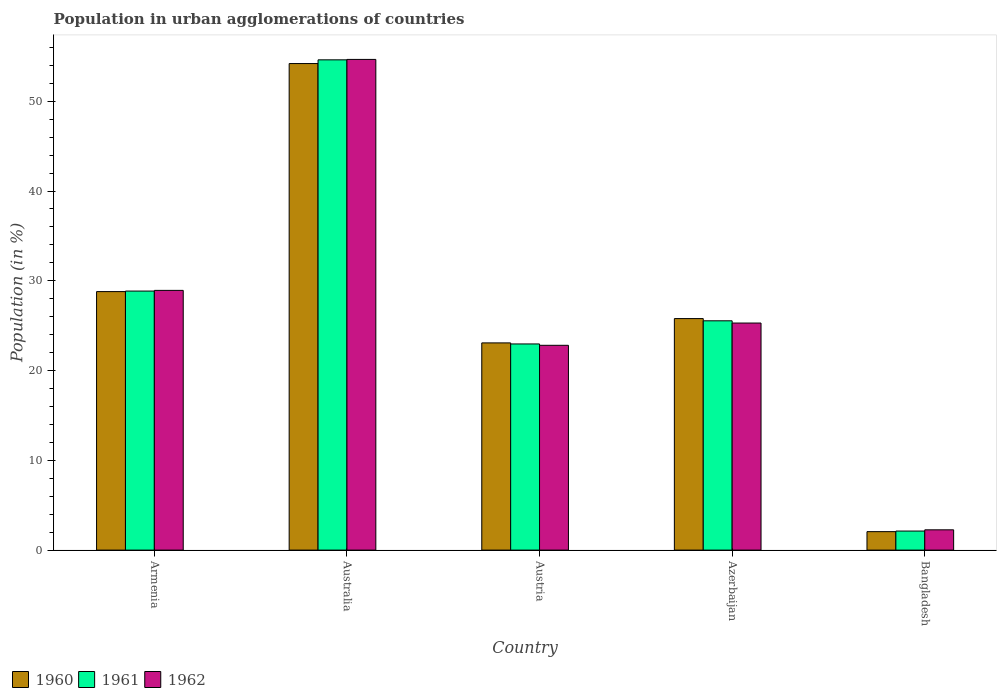How many different coloured bars are there?
Keep it short and to the point. 3. How many groups of bars are there?
Your answer should be very brief. 5. Are the number of bars per tick equal to the number of legend labels?
Keep it short and to the point. Yes. How many bars are there on the 2nd tick from the left?
Provide a short and direct response. 3. In how many cases, is the number of bars for a given country not equal to the number of legend labels?
Give a very brief answer. 0. What is the percentage of population in urban agglomerations in 1961 in Armenia?
Ensure brevity in your answer.  28.85. Across all countries, what is the maximum percentage of population in urban agglomerations in 1962?
Your answer should be compact. 54.66. Across all countries, what is the minimum percentage of population in urban agglomerations in 1962?
Keep it short and to the point. 2.26. In which country was the percentage of population in urban agglomerations in 1961 minimum?
Your answer should be compact. Bangladesh. What is the total percentage of population in urban agglomerations in 1960 in the graph?
Provide a short and direct response. 133.93. What is the difference between the percentage of population in urban agglomerations in 1960 in Australia and that in Austria?
Provide a short and direct response. 31.12. What is the difference between the percentage of population in urban agglomerations in 1962 in Austria and the percentage of population in urban agglomerations in 1961 in Bangladesh?
Keep it short and to the point. 20.69. What is the average percentage of population in urban agglomerations in 1961 per country?
Ensure brevity in your answer.  26.82. What is the difference between the percentage of population in urban agglomerations of/in 1960 and percentage of population in urban agglomerations of/in 1961 in Armenia?
Offer a very short reply. -0.06. In how many countries, is the percentage of population in urban agglomerations in 1960 greater than 46 %?
Your answer should be very brief. 1. What is the ratio of the percentage of population in urban agglomerations in 1961 in Armenia to that in Australia?
Your response must be concise. 0.53. What is the difference between the highest and the second highest percentage of population in urban agglomerations in 1960?
Make the answer very short. -3.01. What is the difference between the highest and the lowest percentage of population in urban agglomerations in 1961?
Give a very brief answer. 52.49. What does the 1st bar from the right in Azerbaijan represents?
Offer a very short reply. 1962. How many bars are there?
Offer a terse response. 15. How many countries are there in the graph?
Ensure brevity in your answer.  5. Are the values on the major ticks of Y-axis written in scientific E-notation?
Offer a terse response. No. Does the graph contain any zero values?
Ensure brevity in your answer.  No. Does the graph contain grids?
Your answer should be compact. No. Where does the legend appear in the graph?
Keep it short and to the point. Bottom left. How are the legend labels stacked?
Ensure brevity in your answer.  Horizontal. What is the title of the graph?
Give a very brief answer. Population in urban agglomerations of countries. What is the label or title of the X-axis?
Keep it short and to the point. Country. What is the label or title of the Y-axis?
Your answer should be very brief. Population (in %). What is the Population (in %) in 1960 in Armenia?
Offer a terse response. 28.8. What is the Population (in %) in 1961 in Armenia?
Keep it short and to the point. 28.85. What is the Population (in %) in 1962 in Armenia?
Provide a short and direct response. 28.93. What is the Population (in %) of 1960 in Australia?
Offer a very short reply. 54.2. What is the Population (in %) of 1961 in Australia?
Your answer should be very brief. 54.62. What is the Population (in %) of 1962 in Australia?
Provide a short and direct response. 54.66. What is the Population (in %) in 1960 in Austria?
Keep it short and to the point. 23.08. What is the Population (in %) in 1961 in Austria?
Give a very brief answer. 22.96. What is the Population (in %) of 1962 in Austria?
Your answer should be compact. 22.81. What is the Population (in %) in 1960 in Azerbaijan?
Make the answer very short. 25.79. What is the Population (in %) of 1961 in Azerbaijan?
Keep it short and to the point. 25.54. What is the Population (in %) of 1962 in Azerbaijan?
Ensure brevity in your answer.  25.29. What is the Population (in %) in 1960 in Bangladesh?
Make the answer very short. 2.06. What is the Population (in %) in 1961 in Bangladesh?
Offer a very short reply. 2.12. What is the Population (in %) in 1962 in Bangladesh?
Keep it short and to the point. 2.26. Across all countries, what is the maximum Population (in %) of 1960?
Provide a short and direct response. 54.2. Across all countries, what is the maximum Population (in %) in 1961?
Provide a succinct answer. 54.62. Across all countries, what is the maximum Population (in %) in 1962?
Offer a very short reply. 54.66. Across all countries, what is the minimum Population (in %) in 1960?
Your response must be concise. 2.06. Across all countries, what is the minimum Population (in %) of 1961?
Ensure brevity in your answer.  2.12. Across all countries, what is the minimum Population (in %) of 1962?
Provide a short and direct response. 2.26. What is the total Population (in %) in 1960 in the graph?
Ensure brevity in your answer.  133.93. What is the total Population (in %) in 1961 in the graph?
Your answer should be very brief. 134.1. What is the total Population (in %) in 1962 in the graph?
Make the answer very short. 133.96. What is the difference between the Population (in %) in 1960 in Armenia and that in Australia?
Provide a short and direct response. -25.4. What is the difference between the Population (in %) in 1961 in Armenia and that in Australia?
Offer a terse response. -25.76. What is the difference between the Population (in %) in 1962 in Armenia and that in Australia?
Your answer should be very brief. -25.73. What is the difference between the Population (in %) of 1960 in Armenia and that in Austria?
Your answer should be very brief. 5.72. What is the difference between the Population (in %) of 1961 in Armenia and that in Austria?
Keep it short and to the point. 5.89. What is the difference between the Population (in %) of 1962 in Armenia and that in Austria?
Provide a succinct answer. 6.12. What is the difference between the Population (in %) in 1960 in Armenia and that in Azerbaijan?
Offer a very short reply. 3.01. What is the difference between the Population (in %) in 1961 in Armenia and that in Azerbaijan?
Keep it short and to the point. 3.31. What is the difference between the Population (in %) in 1962 in Armenia and that in Azerbaijan?
Your response must be concise. 3.64. What is the difference between the Population (in %) in 1960 in Armenia and that in Bangladesh?
Give a very brief answer. 26.74. What is the difference between the Population (in %) in 1961 in Armenia and that in Bangladesh?
Your response must be concise. 26.73. What is the difference between the Population (in %) in 1962 in Armenia and that in Bangladesh?
Ensure brevity in your answer.  26.67. What is the difference between the Population (in %) of 1960 in Australia and that in Austria?
Provide a short and direct response. 31.12. What is the difference between the Population (in %) of 1961 in Australia and that in Austria?
Make the answer very short. 31.65. What is the difference between the Population (in %) in 1962 in Australia and that in Austria?
Your answer should be compact. 31.85. What is the difference between the Population (in %) of 1960 in Australia and that in Azerbaijan?
Your response must be concise. 28.41. What is the difference between the Population (in %) of 1961 in Australia and that in Azerbaijan?
Your response must be concise. 29.07. What is the difference between the Population (in %) of 1962 in Australia and that in Azerbaijan?
Make the answer very short. 29.37. What is the difference between the Population (in %) in 1960 in Australia and that in Bangladesh?
Your answer should be very brief. 52.14. What is the difference between the Population (in %) of 1961 in Australia and that in Bangladesh?
Your answer should be very brief. 52.49. What is the difference between the Population (in %) in 1962 in Australia and that in Bangladesh?
Ensure brevity in your answer.  52.4. What is the difference between the Population (in %) of 1960 in Austria and that in Azerbaijan?
Your answer should be very brief. -2.71. What is the difference between the Population (in %) in 1961 in Austria and that in Azerbaijan?
Make the answer very short. -2.58. What is the difference between the Population (in %) of 1962 in Austria and that in Azerbaijan?
Keep it short and to the point. -2.48. What is the difference between the Population (in %) of 1960 in Austria and that in Bangladesh?
Make the answer very short. 21.03. What is the difference between the Population (in %) in 1961 in Austria and that in Bangladesh?
Offer a terse response. 20.84. What is the difference between the Population (in %) in 1962 in Austria and that in Bangladesh?
Your response must be concise. 20.56. What is the difference between the Population (in %) of 1960 in Azerbaijan and that in Bangladesh?
Ensure brevity in your answer.  23.74. What is the difference between the Population (in %) of 1961 in Azerbaijan and that in Bangladesh?
Keep it short and to the point. 23.42. What is the difference between the Population (in %) in 1962 in Azerbaijan and that in Bangladesh?
Your answer should be compact. 23.04. What is the difference between the Population (in %) of 1960 in Armenia and the Population (in %) of 1961 in Australia?
Offer a terse response. -25.82. What is the difference between the Population (in %) of 1960 in Armenia and the Population (in %) of 1962 in Australia?
Give a very brief answer. -25.86. What is the difference between the Population (in %) in 1961 in Armenia and the Population (in %) in 1962 in Australia?
Your response must be concise. -25.81. What is the difference between the Population (in %) of 1960 in Armenia and the Population (in %) of 1961 in Austria?
Make the answer very short. 5.83. What is the difference between the Population (in %) of 1960 in Armenia and the Population (in %) of 1962 in Austria?
Give a very brief answer. 5.98. What is the difference between the Population (in %) of 1961 in Armenia and the Population (in %) of 1962 in Austria?
Keep it short and to the point. 6.04. What is the difference between the Population (in %) of 1960 in Armenia and the Population (in %) of 1961 in Azerbaijan?
Give a very brief answer. 3.25. What is the difference between the Population (in %) in 1960 in Armenia and the Population (in %) in 1962 in Azerbaijan?
Your response must be concise. 3.5. What is the difference between the Population (in %) of 1961 in Armenia and the Population (in %) of 1962 in Azerbaijan?
Provide a succinct answer. 3.56. What is the difference between the Population (in %) of 1960 in Armenia and the Population (in %) of 1961 in Bangladesh?
Make the answer very short. 26.68. What is the difference between the Population (in %) in 1960 in Armenia and the Population (in %) in 1962 in Bangladesh?
Make the answer very short. 26.54. What is the difference between the Population (in %) in 1961 in Armenia and the Population (in %) in 1962 in Bangladesh?
Give a very brief answer. 26.6. What is the difference between the Population (in %) in 1960 in Australia and the Population (in %) in 1961 in Austria?
Your response must be concise. 31.24. What is the difference between the Population (in %) in 1960 in Australia and the Population (in %) in 1962 in Austria?
Provide a succinct answer. 31.39. What is the difference between the Population (in %) of 1961 in Australia and the Population (in %) of 1962 in Austria?
Make the answer very short. 31.8. What is the difference between the Population (in %) in 1960 in Australia and the Population (in %) in 1961 in Azerbaijan?
Your answer should be compact. 28.66. What is the difference between the Population (in %) in 1960 in Australia and the Population (in %) in 1962 in Azerbaijan?
Your answer should be very brief. 28.91. What is the difference between the Population (in %) in 1961 in Australia and the Population (in %) in 1962 in Azerbaijan?
Give a very brief answer. 29.32. What is the difference between the Population (in %) in 1960 in Australia and the Population (in %) in 1961 in Bangladesh?
Provide a short and direct response. 52.08. What is the difference between the Population (in %) of 1960 in Australia and the Population (in %) of 1962 in Bangladesh?
Provide a short and direct response. 51.94. What is the difference between the Population (in %) in 1961 in Australia and the Population (in %) in 1962 in Bangladesh?
Keep it short and to the point. 52.36. What is the difference between the Population (in %) of 1960 in Austria and the Population (in %) of 1961 in Azerbaijan?
Provide a succinct answer. -2.46. What is the difference between the Population (in %) in 1960 in Austria and the Population (in %) in 1962 in Azerbaijan?
Give a very brief answer. -2.21. What is the difference between the Population (in %) of 1961 in Austria and the Population (in %) of 1962 in Azerbaijan?
Make the answer very short. -2.33. What is the difference between the Population (in %) in 1960 in Austria and the Population (in %) in 1961 in Bangladesh?
Ensure brevity in your answer.  20.96. What is the difference between the Population (in %) of 1960 in Austria and the Population (in %) of 1962 in Bangladesh?
Your answer should be very brief. 20.82. What is the difference between the Population (in %) in 1961 in Austria and the Population (in %) in 1962 in Bangladesh?
Provide a succinct answer. 20.71. What is the difference between the Population (in %) in 1960 in Azerbaijan and the Population (in %) in 1961 in Bangladesh?
Provide a succinct answer. 23.67. What is the difference between the Population (in %) in 1960 in Azerbaijan and the Population (in %) in 1962 in Bangladesh?
Your answer should be very brief. 23.53. What is the difference between the Population (in %) of 1961 in Azerbaijan and the Population (in %) of 1962 in Bangladesh?
Make the answer very short. 23.28. What is the average Population (in %) in 1960 per country?
Keep it short and to the point. 26.79. What is the average Population (in %) of 1961 per country?
Keep it short and to the point. 26.82. What is the average Population (in %) in 1962 per country?
Your answer should be very brief. 26.79. What is the difference between the Population (in %) of 1960 and Population (in %) of 1961 in Armenia?
Provide a short and direct response. -0.06. What is the difference between the Population (in %) of 1960 and Population (in %) of 1962 in Armenia?
Your response must be concise. -0.14. What is the difference between the Population (in %) of 1961 and Population (in %) of 1962 in Armenia?
Make the answer very short. -0.08. What is the difference between the Population (in %) in 1960 and Population (in %) in 1961 in Australia?
Provide a succinct answer. -0.42. What is the difference between the Population (in %) in 1960 and Population (in %) in 1962 in Australia?
Give a very brief answer. -0.46. What is the difference between the Population (in %) of 1961 and Population (in %) of 1962 in Australia?
Keep it short and to the point. -0.05. What is the difference between the Population (in %) in 1960 and Population (in %) in 1961 in Austria?
Your answer should be very brief. 0.12. What is the difference between the Population (in %) of 1960 and Population (in %) of 1962 in Austria?
Keep it short and to the point. 0.27. What is the difference between the Population (in %) in 1961 and Population (in %) in 1962 in Austria?
Provide a short and direct response. 0.15. What is the difference between the Population (in %) in 1960 and Population (in %) in 1961 in Azerbaijan?
Your answer should be compact. 0.25. What is the difference between the Population (in %) of 1960 and Population (in %) of 1962 in Azerbaijan?
Give a very brief answer. 0.5. What is the difference between the Population (in %) of 1961 and Population (in %) of 1962 in Azerbaijan?
Offer a terse response. 0.25. What is the difference between the Population (in %) of 1960 and Population (in %) of 1961 in Bangladesh?
Provide a succinct answer. -0.07. What is the difference between the Population (in %) in 1960 and Population (in %) in 1962 in Bangladesh?
Ensure brevity in your answer.  -0.2. What is the difference between the Population (in %) in 1961 and Population (in %) in 1962 in Bangladesh?
Give a very brief answer. -0.14. What is the ratio of the Population (in %) in 1960 in Armenia to that in Australia?
Provide a succinct answer. 0.53. What is the ratio of the Population (in %) in 1961 in Armenia to that in Australia?
Give a very brief answer. 0.53. What is the ratio of the Population (in %) in 1962 in Armenia to that in Australia?
Your answer should be compact. 0.53. What is the ratio of the Population (in %) of 1960 in Armenia to that in Austria?
Your response must be concise. 1.25. What is the ratio of the Population (in %) in 1961 in Armenia to that in Austria?
Offer a terse response. 1.26. What is the ratio of the Population (in %) in 1962 in Armenia to that in Austria?
Ensure brevity in your answer.  1.27. What is the ratio of the Population (in %) of 1960 in Armenia to that in Azerbaijan?
Give a very brief answer. 1.12. What is the ratio of the Population (in %) of 1961 in Armenia to that in Azerbaijan?
Ensure brevity in your answer.  1.13. What is the ratio of the Population (in %) in 1962 in Armenia to that in Azerbaijan?
Keep it short and to the point. 1.14. What is the ratio of the Population (in %) in 1960 in Armenia to that in Bangladesh?
Your response must be concise. 14.01. What is the ratio of the Population (in %) in 1961 in Armenia to that in Bangladesh?
Your answer should be compact. 13.6. What is the ratio of the Population (in %) of 1962 in Armenia to that in Bangladesh?
Give a very brief answer. 12.81. What is the ratio of the Population (in %) of 1960 in Australia to that in Austria?
Your answer should be compact. 2.35. What is the ratio of the Population (in %) in 1961 in Australia to that in Austria?
Provide a succinct answer. 2.38. What is the ratio of the Population (in %) in 1962 in Australia to that in Austria?
Provide a short and direct response. 2.4. What is the ratio of the Population (in %) in 1960 in Australia to that in Azerbaijan?
Offer a very short reply. 2.1. What is the ratio of the Population (in %) in 1961 in Australia to that in Azerbaijan?
Your answer should be compact. 2.14. What is the ratio of the Population (in %) in 1962 in Australia to that in Azerbaijan?
Your response must be concise. 2.16. What is the ratio of the Population (in %) of 1960 in Australia to that in Bangladesh?
Offer a very short reply. 26.37. What is the ratio of the Population (in %) in 1961 in Australia to that in Bangladesh?
Your response must be concise. 25.74. What is the ratio of the Population (in %) in 1962 in Australia to that in Bangladesh?
Provide a short and direct response. 24.2. What is the ratio of the Population (in %) in 1960 in Austria to that in Azerbaijan?
Give a very brief answer. 0.9. What is the ratio of the Population (in %) of 1961 in Austria to that in Azerbaijan?
Offer a terse response. 0.9. What is the ratio of the Population (in %) in 1962 in Austria to that in Azerbaijan?
Provide a succinct answer. 0.9. What is the ratio of the Population (in %) in 1960 in Austria to that in Bangladesh?
Provide a succinct answer. 11.23. What is the ratio of the Population (in %) of 1961 in Austria to that in Bangladesh?
Ensure brevity in your answer.  10.82. What is the ratio of the Population (in %) of 1962 in Austria to that in Bangladesh?
Provide a short and direct response. 10.1. What is the ratio of the Population (in %) of 1960 in Azerbaijan to that in Bangladesh?
Your answer should be very brief. 12.55. What is the ratio of the Population (in %) in 1961 in Azerbaijan to that in Bangladesh?
Offer a terse response. 12.04. What is the ratio of the Population (in %) of 1962 in Azerbaijan to that in Bangladesh?
Give a very brief answer. 11.2. What is the difference between the highest and the second highest Population (in %) of 1960?
Your response must be concise. 25.4. What is the difference between the highest and the second highest Population (in %) in 1961?
Provide a succinct answer. 25.76. What is the difference between the highest and the second highest Population (in %) of 1962?
Offer a terse response. 25.73. What is the difference between the highest and the lowest Population (in %) of 1960?
Make the answer very short. 52.14. What is the difference between the highest and the lowest Population (in %) of 1961?
Your answer should be very brief. 52.49. What is the difference between the highest and the lowest Population (in %) in 1962?
Give a very brief answer. 52.4. 